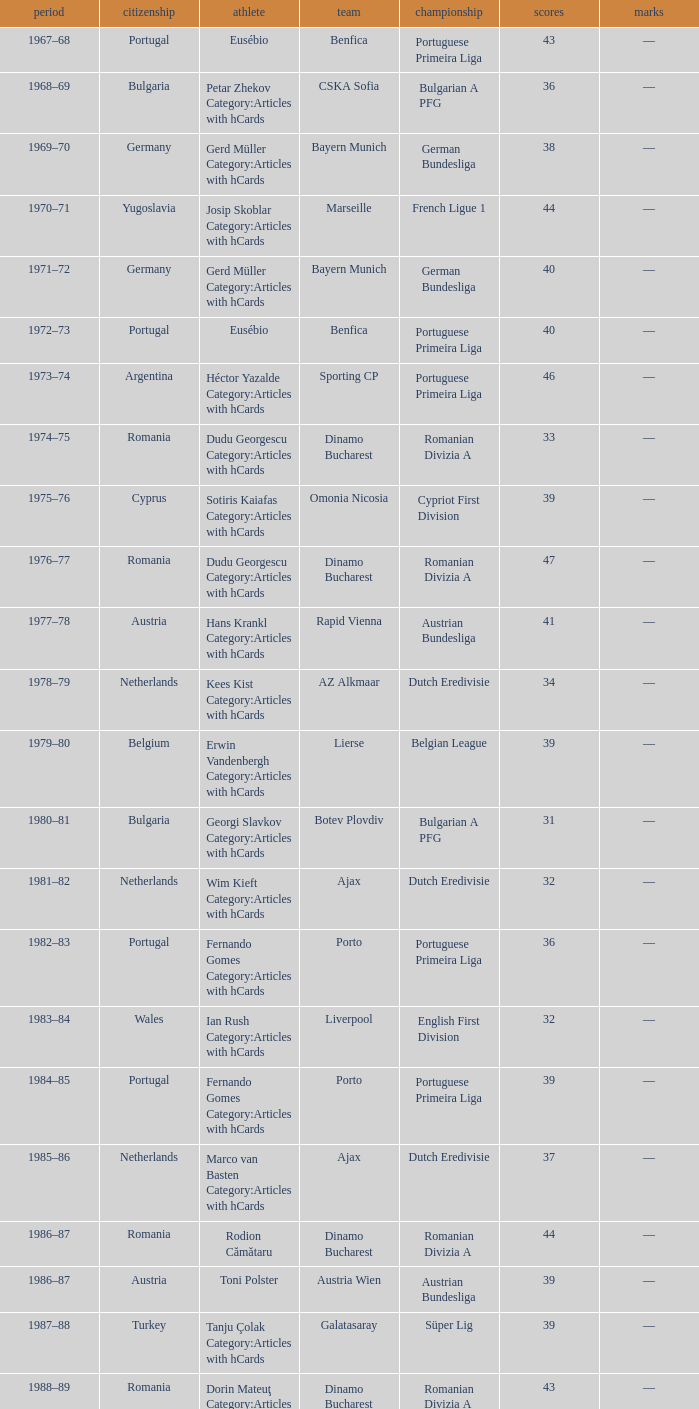Which player was in the Omonia Nicosia club? Sotiris Kaiafas Category:Articles with hCards. 